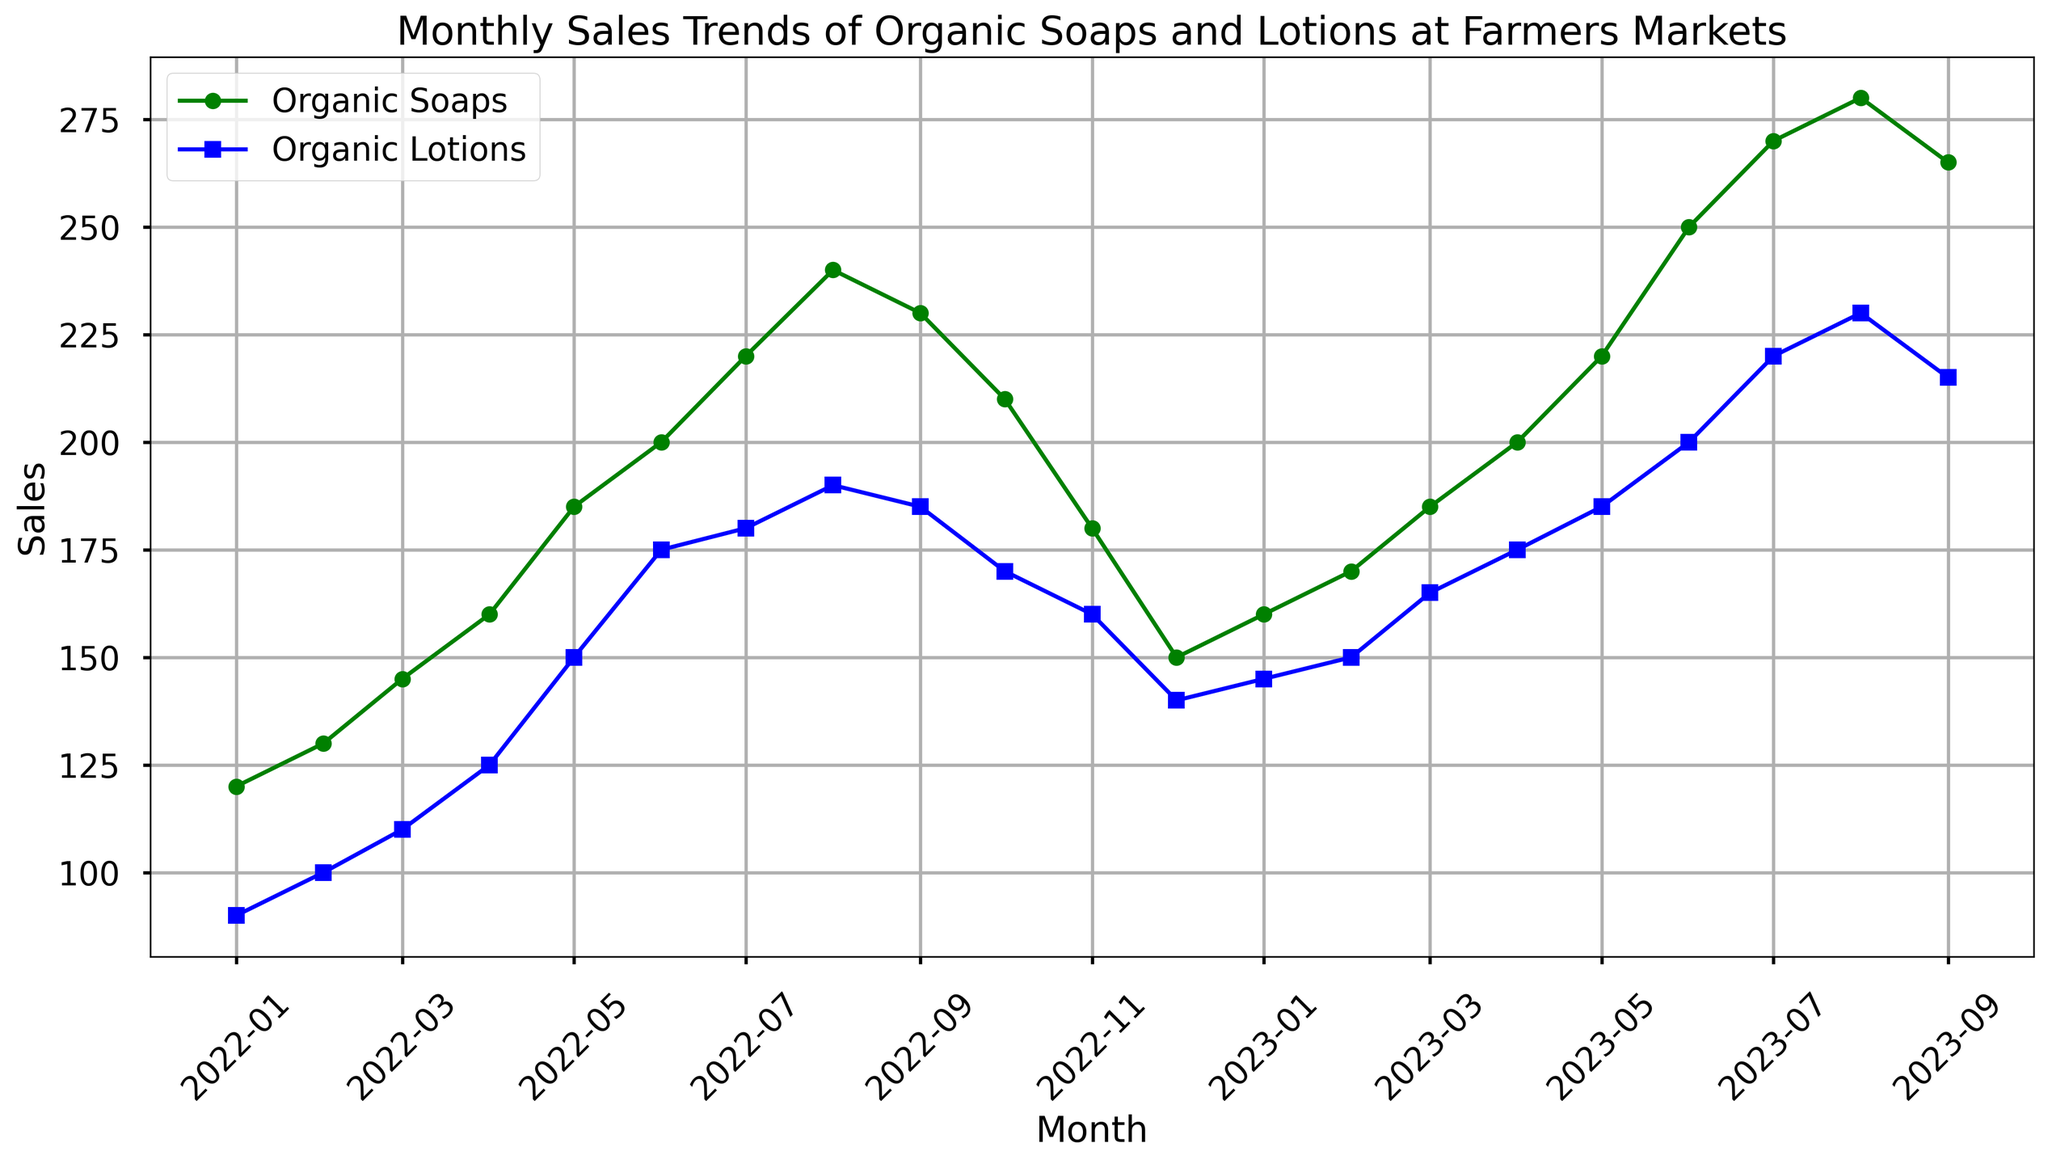What is the overall trend of sales for both organic soaps and lotions over the past year? Both sales show an overall increasing trend. The sales of organic soaps and lotions both increased from January 2022 to September 2023 with some fluctuations in between.
Answer: Increasing Which month had the highest sales for organic soaps and for organic lotions? The highest sales for organic soaps occurred in August 2023 with 280 units sold. For organic lotions, the highest sales were also in August 2023 with 230 units sold.
Answer: August 2023 How do the sales of organic soaps in August 2022 compare to the sales of organic soaps in August 2023? In August 2022, the sales of organic soaps were 240 units, while in August 2023, the sales were 280 units. Therefore, the sales increased by 40 units.
Answer: Increased by 40 units What is the average monthly sales of organic lotions over the past year? To find the average monthly sales, sum all the lotion sales from 2022-09 to 2023-09 and divide by the number of months. The sum of sales is 2,660, and dividing by 12 gives 2,660 / 12 ≈ 221.67.
Answer: 221.67 Between which months did the sales of organic soaps show the largest increase? The largest increase in sales of organic soaps happened between June 2023 (250 units) and July 2023 (270 units), an increase of 20 units.
Answer: June 2023 to July 2023 In which months did the sales of organic lotions decrease? Sales of organic lotions decreased between August 2023 (230 units) to September 2023 (215 units), and from October 2022 (170 units) to November 2022 (160 units).
Answer: August 2023 to September 2023 and October 2022 to November 2022 Which product had a more stable sales trend over the year, organic soaps or organic lotions? The sales of organic lotions show fewer large fluctuations and a more stable trend compared to organic soaps, which have more visible peaks and troughs.
Answer: Organic Lotions If you sum the sales of both organic soaps and organic lotions for January 2023, what is the total? In January 2023, the sales of organic soaps were 160 units and the sales of organic lotions were 145 units. 160 + 145 = 305.
Answer: 305 By how much did the sales of organic soaps decrease from September 2022 to November 2022? Sales of organic soaps were 230 units in September 2022 and 180 units in November 2022. The decrease is 230 - 180 = 50 units.
Answer: 50 units Which month had the lowest sales for organic lotions, and how many units were sold? The lowest sales for organic lotions were in January 2022, with 90 units sold.
Answer: January 2022 with 90 units 